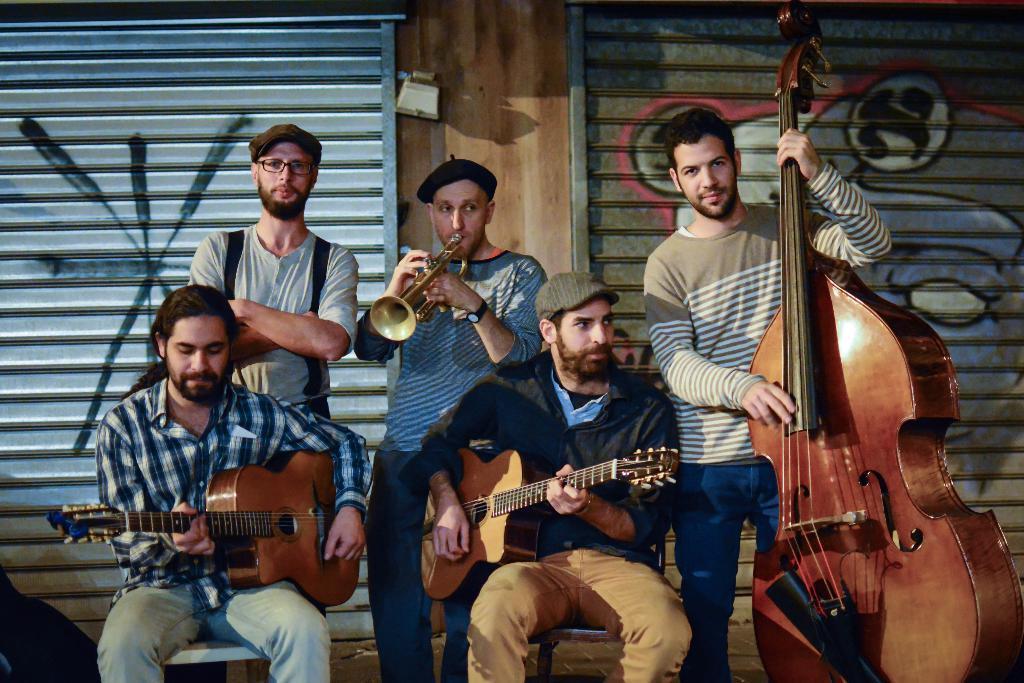Could you give a brief overview of what you see in this image? There are five people. On the right end a person is holding a violin. Two persons are sitting and holding guitar. In the center a person is sitting and having a cap on his head. In the back a person wearing a red t shirt is holding a trumpet. In the background there are shutter. 